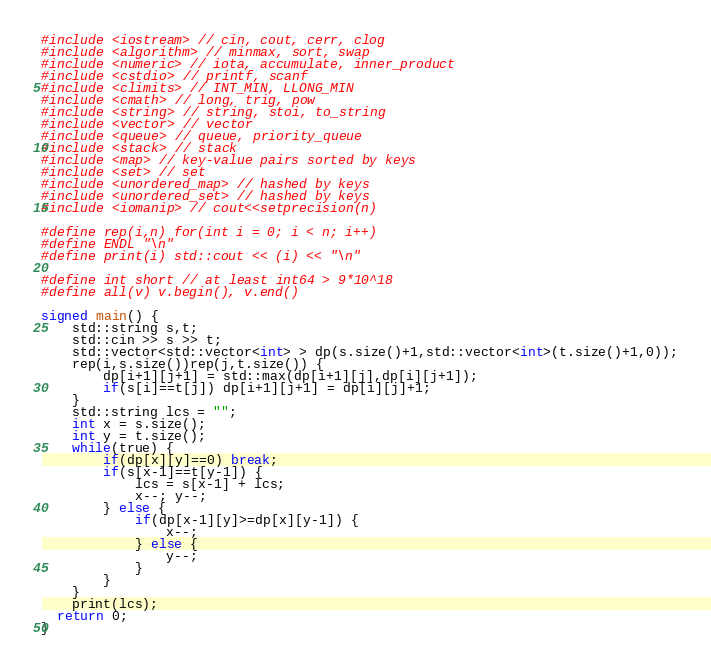<code> <loc_0><loc_0><loc_500><loc_500><_C++_>#include <iostream> // cin, cout, cerr, clog
#include <algorithm> // minmax, sort, swap
#include <numeric> // iota, accumulate, inner_product
#include <cstdio> // printf, scanf
#include <climits> // INT_MIN, LLONG_MIN
#include <cmath> // long, trig, pow
#include <string> // string, stoi, to_string
#include <vector> // vector
#include <queue> // queue, priority_queue
#include <stack> // stack
#include <map> // key-value pairs sorted by keys
#include <set> // set
#include <unordered_map> // hashed by keys
#include <unordered_set> // hashed by keys
#include <iomanip> // cout<<setprecision(n)

#define rep(i,n) for(int i = 0; i < n; i++)
#define ENDL "\n"
#define print(i) std::cout << (i) << "\n"

#define int short // at least int64 > 9*10^18
#define all(v) v.begin(), v.end()

signed main() {
	std::string s,t;
	std::cin >> s >> t;
	std::vector<std::vector<int> > dp(s.size()+1,std::vector<int>(t.size()+1,0));
	rep(i,s.size())rep(j,t.size()) {
		dp[i+1][j+1] = std::max(dp[i+1][j],dp[i][j+1]);
		if(s[i]==t[j]) dp[i+1][j+1] = dp[i][j]+1;
	}
	std::string lcs = "";
	int x = s.size();
	int y = t.size();
	while(true) {
		if(dp[x][y]==0) break;
		if(s[x-1]==t[y-1]) {
			lcs = s[x-1] + lcs;
			x--; y--;
		} else {
			if(dp[x-1][y]>=dp[x][y-1]) {
				x--;
			} else {
				y--;
			}
		}
	}
	print(lcs);
  return 0;
}
</code> 